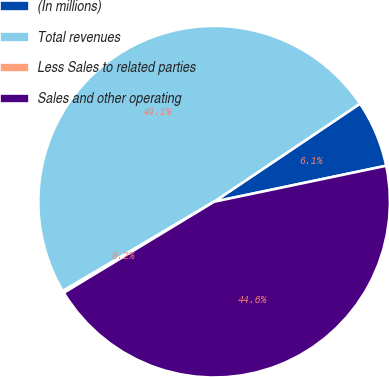Convert chart. <chart><loc_0><loc_0><loc_500><loc_500><pie_chart><fcel>(In millions)<fcel>Total revenues<fcel>Less Sales to related parties<fcel>Sales and other operating<nl><fcel>6.14%<fcel>49.07%<fcel>0.18%<fcel>44.61%<nl></chart> 